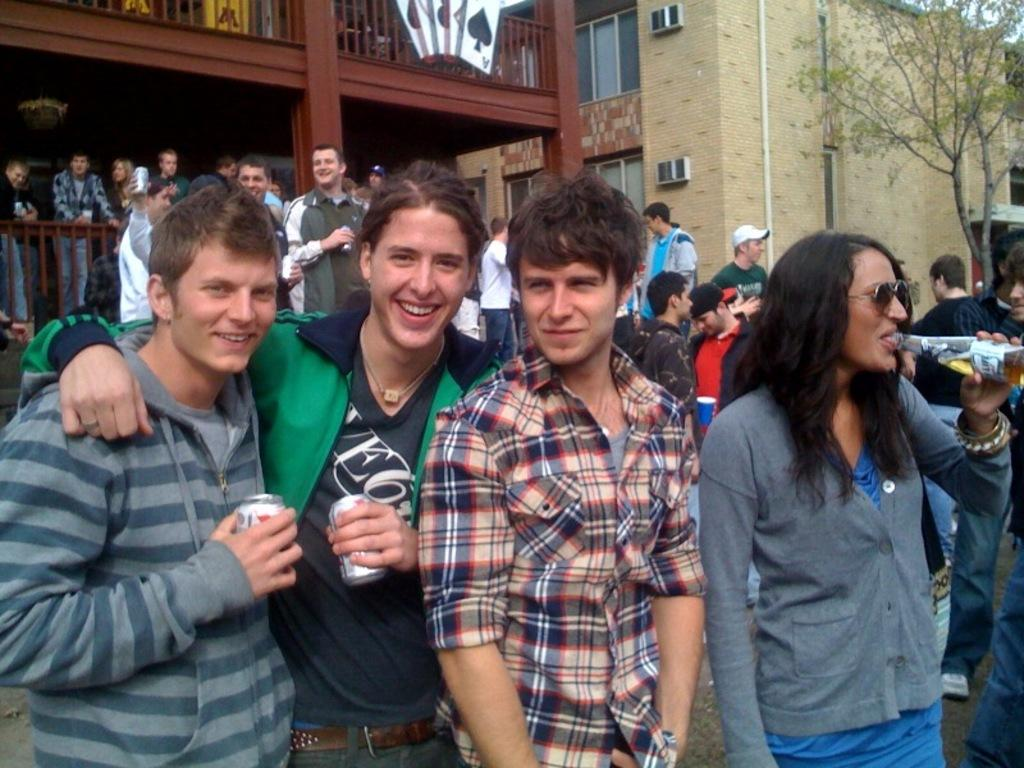What are the people in the image doing? The people in the image are standing on the road. What can be seen behind the people? There is a building behind the people. What type of vegetation is on the right side of the image? There is a tree on the right side of the image. What color is the cat that is coughing during the meeting in the image? There is no cat or meeting present in the image, so there is no cat to observe coughing. 